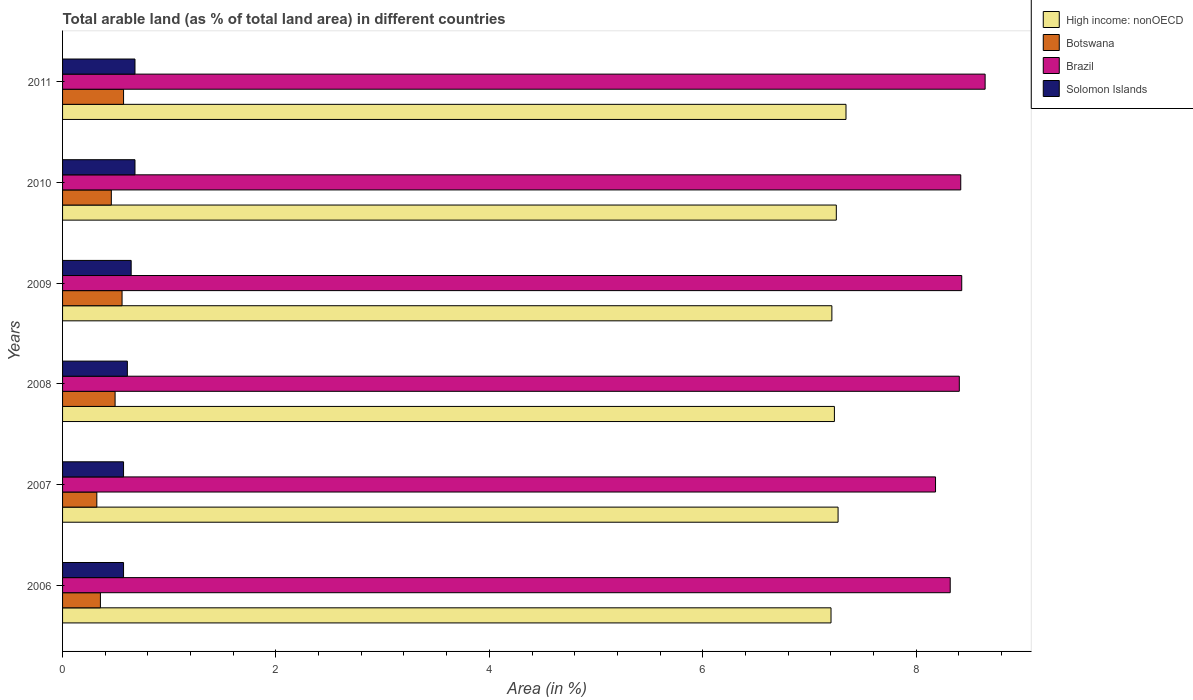How many different coloured bars are there?
Offer a terse response. 4. How many groups of bars are there?
Your answer should be very brief. 6. Are the number of bars per tick equal to the number of legend labels?
Ensure brevity in your answer.  Yes. How many bars are there on the 3rd tick from the top?
Offer a terse response. 4. How many bars are there on the 5th tick from the bottom?
Offer a very short reply. 4. What is the label of the 1st group of bars from the top?
Make the answer very short. 2011. In how many cases, is the number of bars for a given year not equal to the number of legend labels?
Ensure brevity in your answer.  0. What is the percentage of arable land in High income: nonOECD in 2008?
Your answer should be very brief. 7.23. Across all years, what is the maximum percentage of arable land in High income: nonOECD?
Offer a very short reply. 7.34. Across all years, what is the minimum percentage of arable land in High income: nonOECD?
Ensure brevity in your answer.  7.2. What is the total percentage of arable land in High income: nonOECD in the graph?
Offer a very short reply. 43.51. What is the difference between the percentage of arable land in Solomon Islands in 2007 and that in 2011?
Provide a short and direct response. -0.11. What is the difference between the percentage of arable land in Solomon Islands in 2010 and the percentage of arable land in Botswana in 2007?
Ensure brevity in your answer.  0.36. What is the average percentage of arable land in Solomon Islands per year?
Offer a terse response. 0.63. In the year 2011, what is the difference between the percentage of arable land in Botswana and percentage of arable land in High income: nonOECD?
Your answer should be compact. -6.77. What is the ratio of the percentage of arable land in Botswana in 2006 to that in 2007?
Your answer should be very brief. 1.1. Is the difference between the percentage of arable land in Botswana in 2008 and 2009 greater than the difference between the percentage of arable land in High income: nonOECD in 2008 and 2009?
Ensure brevity in your answer.  No. What is the difference between the highest and the second highest percentage of arable land in Solomon Islands?
Your response must be concise. 0. What is the difference between the highest and the lowest percentage of arable land in Botswana?
Give a very brief answer. 0.25. Is it the case that in every year, the sum of the percentage of arable land in Solomon Islands and percentage of arable land in High income: nonOECD is greater than the sum of percentage of arable land in Brazil and percentage of arable land in Botswana?
Provide a short and direct response. No. What does the 3rd bar from the top in 2006 represents?
Your response must be concise. Botswana. What does the 2nd bar from the bottom in 2009 represents?
Your response must be concise. Botswana. Is it the case that in every year, the sum of the percentage of arable land in Solomon Islands and percentage of arable land in Brazil is greater than the percentage of arable land in High income: nonOECD?
Provide a succinct answer. Yes. How many years are there in the graph?
Offer a terse response. 6. What is the difference between two consecutive major ticks on the X-axis?
Make the answer very short. 2. Does the graph contain any zero values?
Keep it short and to the point. No. Where does the legend appear in the graph?
Offer a terse response. Top right. How are the legend labels stacked?
Provide a succinct answer. Vertical. What is the title of the graph?
Offer a terse response. Total arable land (as % of total land area) in different countries. Does "Sub-Saharan Africa (developing only)" appear as one of the legend labels in the graph?
Provide a short and direct response. No. What is the label or title of the X-axis?
Keep it short and to the point. Area (in %). What is the label or title of the Y-axis?
Your answer should be very brief. Years. What is the Area (in %) in High income: nonOECD in 2006?
Provide a succinct answer. 7.2. What is the Area (in %) in Botswana in 2006?
Provide a short and direct response. 0.35. What is the Area (in %) of Brazil in 2006?
Your response must be concise. 8.32. What is the Area (in %) of Solomon Islands in 2006?
Your response must be concise. 0.57. What is the Area (in %) of High income: nonOECD in 2007?
Provide a short and direct response. 7.27. What is the Area (in %) of Botswana in 2007?
Offer a terse response. 0.32. What is the Area (in %) in Brazil in 2007?
Offer a terse response. 8.18. What is the Area (in %) in Solomon Islands in 2007?
Provide a short and direct response. 0.57. What is the Area (in %) of High income: nonOECD in 2008?
Keep it short and to the point. 7.23. What is the Area (in %) in Botswana in 2008?
Offer a very short reply. 0.49. What is the Area (in %) in Brazil in 2008?
Offer a terse response. 8.4. What is the Area (in %) in Solomon Islands in 2008?
Your answer should be very brief. 0.61. What is the Area (in %) of High income: nonOECD in 2009?
Ensure brevity in your answer.  7.21. What is the Area (in %) of Botswana in 2009?
Ensure brevity in your answer.  0.56. What is the Area (in %) in Brazil in 2009?
Provide a succinct answer. 8.43. What is the Area (in %) of Solomon Islands in 2009?
Your answer should be very brief. 0.64. What is the Area (in %) in High income: nonOECD in 2010?
Your answer should be very brief. 7.25. What is the Area (in %) in Botswana in 2010?
Offer a terse response. 0.46. What is the Area (in %) in Brazil in 2010?
Keep it short and to the point. 8.42. What is the Area (in %) of Solomon Islands in 2010?
Your answer should be compact. 0.68. What is the Area (in %) of High income: nonOECD in 2011?
Your response must be concise. 7.34. What is the Area (in %) in Botswana in 2011?
Provide a succinct answer. 0.57. What is the Area (in %) in Brazil in 2011?
Keep it short and to the point. 8.65. What is the Area (in %) in Solomon Islands in 2011?
Give a very brief answer. 0.68. Across all years, what is the maximum Area (in %) of High income: nonOECD?
Make the answer very short. 7.34. Across all years, what is the maximum Area (in %) in Botswana?
Make the answer very short. 0.57. Across all years, what is the maximum Area (in %) of Brazil?
Provide a short and direct response. 8.65. Across all years, what is the maximum Area (in %) in Solomon Islands?
Ensure brevity in your answer.  0.68. Across all years, what is the minimum Area (in %) of High income: nonOECD?
Ensure brevity in your answer.  7.2. Across all years, what is the minimum Area (in %) of Botswana?
Make the answer very short. 0.32. Across all years, what is the minimum Area (in %) in Brazil?
Offer a terse response. 8.18. Across all years, what is the minimum Area (in %) of Solomon Islands?
Give a very brief answer. 0.57. What is the total Area (in %) in High income: nonOECD in the graph?
Keep it short and to the point. 43.51. What is the total Area (in %) in Botswana in the graph?
Make the answer very short. 2.75. What is the total Area (in %) of Brazil in the graph?
Provide a succinct answer. 50.4. What is the total Area (in %) in Solomon Islands in the graph?
Provide a short and direct response. 3.75. What is the difference between the Area (in %) in High income: nonOECD in 2006 and that in 2007?
Offer a very short reply. -0.07. What is the difference between the Area (in %) of Botswana in 2006 and that in 2007?
Your response must be concise. 0.03. What is the difference between the Area (in %) in Brazil in 2006 and that in 2007?
Your response must be concise. 0.14. What is the difference between the Area (in %) of High income: nonOECD in 2006 and that in 2008?
Your answer should be compact. -0.03. What is the difference between the Area (in %) in Botswana in 2006 and that in 2008?
Provide a short and direct response. -0.14. What is the difference between the Area (in %) of Brazil in 2006 and that in 2008?
Your answer should be very brief. -0.09. What is the difference between the Area (in %) of Solomon Islands in 2006 and that in 2008?
Provide a short and direct response. -0.04. What is the difference between the Area (in %) of High income: nonOECD in 2006 and that in 2009?
Provide a short and direct response. -0.01. What is the difference between the Area (in %) of Botswana in 2006 and that in 2009?
Give a very brief answer. -0.2. What is the difference between the Area (in %) of Brazil in 2006 and that in 2009?
Ensure brevity in your answer.  -0.11. What is the difference between the Area (in %) of Solomon Islands in 2006 and that in 2009?
Provide a succinct answer. -0.07. What is the difference between the Area (in %) of High income: nonOECD in 2006 and that in 2010?
Provide a short and direct response. -0.05. What is the difference between the Area (in %) of Botswana in 2006 and that in 2010?
Give a very brief answer. -0.1. What is the difference between the Area (in %) of Brazil in 2006 and that in 2010?
Provide a short and direct response. -0.1. What is the difference between the Area (in %) of Solomon Islands in 2006 and that in 2010?
Ensure brevity in your answer.  -0.11. What is the difference between the Area (in %) in High income: nonOECD in 2006 and that in 2011?
Offer a terse response. -0.14. What is the difference between the Area (in %) of Botswana in 2006 and that in 2011?
Ensure brevity in your answer.  -0.22. What is the difference between the Area (in %) in Brazil in 2006 and that in 2011?
Provide a succinct answer. -0.33. What is the difference between the Area (in %) in Solomon Islands in 2006 and that in 2011?
Give a very brief answer. -0.11. What is the difference between the Area (in %) in High income: nonOECD in 2007 and that in 2008?
Provide a succinct answer. 0.03. What is the difference between the Area (in %) of Botswana in 2007 and that in 2008?
Provide a short and direct response. -0.17. What is the difference between the Area (in %) in Brazil in 2007 and that in 2008?
Ensure brevity in your answer.  -0.22. What is the difference between the Area (in %) in Solomon Islands in 2007 and that in 2008?
Make the answer very short. -0.04. What is the difference between the Area (in %) in High income: nonOECD in 2007 and that in 2009?
Your answer should be very brief. 0.06. What is the difference between the Area (in %) of Botswana in 2007 and that in 2009?
Keep it short and to the point. -0.24. What is the difference between the Area (in %) in Brazil in 2007 and that in 2009?
Offer a very short reply. -0.25. What is the difference between the Area (in %) in Solomon Islands in 2007 and that in 2009?
Provide a succinct answer. -0.07. What is the difference between the Area (in %) in High income: nonOECD in 2007 and that in 2010?
Give a very brief answer. 0.02. What is the difference between the Area (in %) of Botswana in 2007 and that in 2010?
Your answer should be very brief. -0.14. What is the difference between the Area (in %) in Brazil in 2007 and that in 2010?
Offer a very short reply. -0.24. What is the difference between the Area (in %) in Solomon Islands in 2007 and that in 2010?
Provide a succinct answer. -0.11. What is the difference between the Area (in %) in High income: nonOECD in 2007 and that in 2011?
Offer a very short reply. -0.07. What is the difference between the Area (in %) in Botswana in 2007 and that in 2011?
Your answer should be compact. -0.25. What is the difference between the Area (in %) of Brazil in 2007 and that in 2011?
Keep it short and to the point. -0.46. What is the difference between the Area (in %) of Solomon Islands in 2007 and that in 2011?
Keep it short and to the point. -0.11. What is the difference between the Area (in %) of High income: nonOECD in 2008 and that in 2009?
Provide a succinct answer. 0.02. What is the difference between the Area (in %) of Botswana in 2008 and that in 2009?
Offer a terse response. -0.07. What is the difference between the Area (in %) in Brazil in 2008 and that in 2009?
Your answer should be very brief. -0.02. What is the difference between the Area (in %) in Solomon Islands in 2008 and that in 2009?
Your answer should be compact. -0.04. What is the difference between the Area (in %) of High income: nonOECD in 2008 and that in 2010?
Ensure brevity in your answer.  -0.02. What is the difference between the Area (in %) in Botswana in 2008 and that in 2010?
Provide a succinct answer. 0.04. What is the difference between the Area (in %) of Brazil in 2008 and that in 2010?
Make the answer very short. -0.01. What is the difference between the Area (in %) of Solomon Islands in 2008 and that in 2010?
Offer a terse response. -0.07. What is the difference between the Area (in %) of High income: nonOECD in 2008 and that in 2011?
Your answer should be very brief. -0.11. What is the difference between the Area (in %) in Botswana in 2008 and that in 2011?
Your response must be concise. -0.08. What is the difference between the Area (in %) in Brazil in 2008 and that in 2011?
Make the answer very short. -0.24. What is the difference between the Area (in %) in Solomon Islands in 2008 and that in 2011?
Your response must be concise. -0.07. What is the difference between the Area (in %) of High income: nonOECD in 2009 and that in 2010?
Your answer should be very brief. -0.04. What is the difference between the Area (in %) of Botswana in 2009 and that in 2010?
Keep it short and to the point. 0.1. What is the difference between the Area (in %) of Brazil in 2009 and that in 2010?
Offer a terse response. 0.01. What is the difference between the Area (in %) of Solomon Islands in 2009 and that in 2010?
Make the answer very short. -0.04. What is the difference between the Area (in %) in High income: nonOECD in 2009 and that in 2011?
Provide a short and direct response. -0.13. What is the difference between the Area (in %) in Botswana in 2009 and that in 2011?
Your response must be concise. -0.01. What is the difference between the Area (in %) of Brazil in 2009 and that in 2011?
Give a very brief answer. -0.22. What is the difference between the Area (in %) of Solomon Islands in 2009 and that in 2011?
Your response must be concise. -0.04. What is the difference between the Area (in %) in High income: nonOECD in 2010 and that in 2011?
Provide a succinct answer. -0.09. What is the difference between the Area (in %) in Botswana in 2010 and that in 2011?
Your answer should be very brief. -0.11. What is the difference between the Area (in %) in Brazil in 2010 and that in 2011?
Your response must be concise. -0.23. What is the difference between the Area (in %) in High income: nonOECD in 2006 and the Area (in %) in Botswana in 2007?
Offer a very short reply. 6.88. What is the difference between the Area (in %) in High income: nonOECD in 2006 and the Area (in %) in Brazil in 2007?
Offer a terse response. -0.98. What is the difference between the Area (in %) of High income: nonOECD in 2006 and the Area (in %) of Solomon Islands in 2007?
Keep it short and to the point. 6.63. What is the difference between the Area (in %) in Botswana in 2006 and the Area (in %) in Brazil in 2007?
Provide a succinct answer. -7.83. What is the difference between the Area (in %) in Botswana in 2006 and the Area (in %) in Solomon Islands in 2007?
Provide a short and direct response. -0.22. What is the difference between the Area (in %) of Brazil in 2006 and the Area (in %) of Solomon Islands in 2007?
Offer a terse response. 7.75. What is the difference between the Area (in %) of High income: nonOECD in 2006 and the Area (in %) of Botswana in 2008?
Ensure brevity in your answer.  6.71. What is the difference between the Area (in %) of High income: nonOECD in 2006 and the Area (in %) of Brazil in 2008?
Provide a succinct answer. -1.2. What is the difference between the Area (in %) in High income: nonOECD in 2006 and the Area (in %) in Solomon Islands in 2008?
Your answer should be very brief. 6.6. What is the difference between the Area (in %) of Botswana in 2006 and the Area (in %) of Brazil in 2008?
Your answer should be very brief. -8.05. What is the difference between the Area (in %) of Botswana in 2006 and the Area (in %) of Solomon Islands in 2008?
Give a very brief answer. -0.25. What is the difference between the Area (in %) in Brazil in 2006 and the Area (in %) in Solomon Islands in 2008?
Offer a very short reply. 7.71. What is the difference between the Area (in %) of High income: nonOECD in 2006 and the Area (in %) of Botswana in 2009?
Give a very brief answer. 6.64. What is the difference between the Area (in %) in High income: nonOECD in 2006 and the Area (in %) in Brazil in 2009?
Give a very brief answer. -1.23. What is the difference between the Area (in %) in High income: nonOECD in 2006 and the Area (in %) in Solomon Islands in 2009?
Provide a short and direct response. 6.56. What is the difference between the Area (in %) in Botswana in 2006 and the Area (in %) in Brazil in 2009?
Ensure brevity in your answer.  -8.07. What is the difference between the Area (in %) in Botswana in 2006 and the Area (in %) in Solomon Islands in 2009?
Your answer should be compact. -0.29. What is the difference between the Area (in %) in Brazil in 2006 and the Area (in %) in Solomon Islands in 2009?
Ensure brevity in your answer.  7.68. What is the difference between the Area (in %) of High income: nonOECD in 2006 and the Area (in %) of Botswana in 2010?
Give a very brief answer. 6.75. What is the difference between the Area (in %) in High income: nonOECD in 2006 and the Area (in %) in Brazil in 2010?
Provide a succinct answer. -1.22. What is the difference between the Area (in %) of High income: nonOECD in 2006 and the Area (in %) of Solomon Islands in 2010?
Your answer should be compact. 6.52. What is the difference between the Area (in %) in Botswana in 2006 and the Area (in %) in Brazil in 2010?
Keep it short and to the point. -8.06. What is the difference between the Area (in %) in Botswana in 2006 and the Area (in %) in Solomon Islands in 2010?
Your response must be concise. -0.32. What is the difference between the Area (in %) in Brazil in 2006 and the Area (in %) in Solomon Islands in 2010?
Your answer should be very brief. 7.64. What is the difference between the Area (in %) in High income: nonOECD in 2006 and the Area (in %) in Botswana in 2011?
Make the answer very short. 6.63. What is the difference between the Area (in %) in High income: nonOECD in 2006 and the Area (in %) in Brazil in 2011?
Make the answer very short. -1.44. What is the difference between the Area (in %) of High income: nonOECD in 2006 and the Area (in %) of Solomon Islands in 2011?
Make the answer very short. 6.52. What is the difference between the Area (in %) in Botswana in 2006 and the Area (in %) in Brazil in 2011?
Make the answer very short. -8.29. What is the difference between the Area (in %) in Botswana in 2006 and the Area (in %) in Solomon Islands in 2011?
Your answer should be very brief. -0.32. What is the difference between the Area (in %) in Brazil in 2006 and the Area (in %) in Solomon Islands in 2011?
Ensure brevity in your answer.  7.64. What is the difference between the Area (in %) in High income: nonOECD in 2007 and the Area (in %) in Botswana in 2008?
Provide a short and direct response. 6.78. What is the difference between the Area (in %) of High income: nonOECD in 2007 and the Area (in %) of Brazil in 2008?
Ensure brevity in your answer.  -1.14. What is the difference between the Area (in %) in High income: nonOECD in 2007 and the Area (in %) in Solomon Islands in 2008?
Offer a very short reply. 6.66. What is the difference between the Area (in %) in Botswana in 2007 and the Area (in %) in Brazil in 2008?
Give a very brief answer. -8.08. What is the difference between the Area (in %) of Botswana in 2007 and the Area (in %) of Solomon Islands in 2008?
Your answer should be compact. -0.29. What is the difference between the Area (in %) of Brazil in 2007 and the Area (in %) of Solomon Islands in 2008?
Your response must be concise. 7.57. What is the difference between the Area (in %) of High income: nonOECD in 2007 and the Area (in %) of Botswana in 2009?
Your response must be concise. 6.71. What is the difference between the Area (in %) of High income: nonOECD in 2007 and the Area (in %) of Brazil in 2009?
Give a very brief answer. -1.16. What is the difference between the Area (in %) in High income: nonOECD in 2007 and the Area (in %) in Solomon Islands in 2009?
Provide a short and direct response. 6.63. What is the difference between the Area (in %) of Botswana in 2007 and the Area (in %) of Brazil in 2009?
Offer a very short reply. -8.11. What is the difference between the Area (in %) of Botswana in 2007 and the Area (in %) of Solomon Islands in 2009?
Ensure brevity in your answer.  -0.32. What is the difference between the Area (in %) in Brazil in 2007 and the Area (in %) in Solomon Islands in 2009?
Your answer should be very brief. 7.54. What is the difference between the Area (in %) in High income: nonOECD in 2007 and the Area (in %) in Botswana in 2010?
Your answer should be very brief. 6.81. What is the difference between the Area (in %) of High income: nonOECD in 2007 and the Area (in %) of Brazil in 2010?
Ensure brevity in your answer.  -1.15. What is the difference between the Area (in %) in High income: nonOECD in 2007 and the Area (in %) in Solomon Islands in 2010?
Offer a terse response. 6.59. What is the difference between the Area (in %) in Botswana in 2007 and the Area (in %) in Brazil in 2010?
Make the answer very short. -8.1. What is the difference between the Area (in %) of Botswana in 2007 and the Area (in %) of Solomon Islands in 2010?
Your answer should be compact. -0.36. What is the difference between the Area (in %) in Brazil in 2007 and the Area (in %) in Solomon Islands in 2010?
Provide a succinct answer. 7.5. What is the difference between the Area (in %) of High income: nonOECD in 2007 and the Area (in %) of Botswana in 2011?
Your answer should be compact. 6.7. What is the difference between the Area (in %) of High income: nonOECD in 2007 and the Area (in %) of Brazil in 2011?
Ensure brevity in your answer.  -1.38. What is the difference between the Area (in %) of High income: nonOECD in 2007 and the Area (in %) of Solomon Islands in 2011?
Your answer should be compact. 6.59. What is the difference between the Area (in %) of Botswana in 2007 and the Area (in %) of Brazil in 2011?
Provide a succinct answer. -8.33. What is the difference between the Area (in %) of Botswana in 2007 and the Area (in %) of Solomon Islands in 2011?
Your response must be concise. -0.36. What is the difference between the Area (in %) in Brazil in 2007 and the Area (in %) in Solomon Islands in 2011?
Your response must be concise. 7.5. What is the difference between the Area (in %) of High income: nonOECD in 2008 and the Area (in %) of Botswana in 2009?
Your response must be concise. 6.68. What is the difference between the Area (in %) in High income: nonOECD in 2008 and the Area (in %) in Brazil in 2009?
Provide a short and direct response. -1.19. What is the difference between the Area (in %) of High income: nonOECD in 2008 and the Area (in %) of Solomon Islands in 2009?
Your response must be concise. 6.59. What is the difference between the Area (in %) of Botswana in 2008 and the Area (in %) of Brazil in 2009?
Your response must be concise. -7.94. What is the difference between the Area (in %) of Botswana in 2008 and the Area (in %) of Solomon Islands in 2009?
Your response must be concise. -0.15. What is the difference between the Area (in %) of Brazil in 2008 and the Area (in %) of Solomon Islands in 2009?
Offer a very short reply. 7.76. What is the difference between the Area (in %) of High income: nonOECD in 2008 and the Area (in %) of Botswana in 2010?
Your answer should be compact. 6.78. What is the difference between the Area (in %) of High income: nonOECD in 2008 and the Area (in %) of Brazil in 2010?
Your answer should be compact. -1.18. What is the difference between the Area (in %) in High income: nonOECD in 2008 and the Area (in %) in Solomon Islands in 2010?
Ensure brevity in your answer.  6.56. What is the difference between the Area (in %) in Botswana in 2008 and the Area (in %) in Brazil in 2010?
Provide a short and direct response. -7.93. What is the difference between the Area (in %) in Botswana in 2008 and the Area (in %) in Solomon Islands in 2010?
Ensure brevity in your answer.  -0.19. What is the difference between the Area (in %) of Brazil in 2008 and the Area (in %) of Solomon Islands in 2010?
Offer a terse response. 7.73. What is the difference between the Area (in %) in High income: nonOECD in 2008 and the Area (in %) in Botswana in 2011?
Your response must be concise. 6.66. What is the difference between the Area (in %) of High income: nonOECD in 2008 and the Area (in %) of Brazil in 2011?
Your answer should be compact. -1.41. What is the difference between the Area (in %) in High income: nonOECD in 2008 and the Area (in %) in Solomon Islands in 2011?
Provide a succinct answer. 6.56. What is the difference between the Area (in %) in Botswana in 2008 and the Area (in %) in Brazil in 2011?
Offer a very short reply. -8.15. What is the difference between the Area (in %) of Botswana in 2008 and the Area (in %) of Solomon Islands in 2011?
Keep it short and to the point. -0.19. What is the difference between the Area (in %) in Brazil in 2008 and the Area (in %) in Solomon Islands in 2011?
Offer a very short reply. 7.73. What is the difference between the Area (in %) of High income: nonOECD in 2009 and the Area (in %) of Botswana in 2010?
Provide a succinct answer. 6.75. What is the difference between the Area (in %) of High income: nonOECD in 2009 and the Area (in %) of Brazil in 2010?
Ensure brevity in your answer.  -1.21. What is the difference between the Area (in %) of High income: nonOECD in 2009 and the Area (in %) of Solomon Islands in 2010?
Provide a succinct answer. 6.53. What is the difference between the Area (in %) in Botswana in 2009 and the Area (in %) in Brazil in 2010?
Your answer should be very brief. -7.86. What is the difference between the Area (in %) of Botswana in 2009 and the Area (in %) of Solomon Islands in 2010?
Make the answer very short. -0.12. What is the difference between the Area (in %) of Brazil in 2009 and the Area (in %) of Solomon Islands in 2010?
Make the answer very short. 7.75. What is the difference between the Area (in %) in High income: nonOECD in 2009 and the Area (in %) in Botswana in 2011?
Make the answer very short. 6.64. What is the difference between the Area (in %) in High income: nonOECD in 2009 and the Area (in %) in Brazil in 2011?
Ensure brevity in your answer.  -1.44. What is the difference between the Area (in %) in High income: nonOECD in 2009 and the Area (in %) in Solomon Islands in 2011?
Your response must be concise. 6.53. What is the difference between the Area (in %) in Botswana in 2009 and the Area (in %) in Brazil in 2011?
Give a very brief answer. -8.09. What is the difference between the Area (in %) in Botswana in 2009 and the Area (in %) in Solomon Islands in 2011?
Your answer should be very brief. -0.12. What is the difference between the Area (in %) in Brazil in 2009 and the Area (in %) in Solomon Islands in 2011?
Provide a succinct answer. 7.75. What is the difference between the Area (in %) in High income: nonOECD in 2010 and the Area (in %) in Botswana in 2011?
Provide a succinct answer. 6.68. What is the difference between the Area (in %) in High income: nonOECD in 2010 and the Area (in %) in Brazil in 2011?
Your answer should be compact. -1.39. What is the difference between the Area (in %) of High income: nonOECD in 2010 and the Area (in %) of Solomon Islands in 2011?
Your answer should be compact. 6.57. What is the difference between the Area (in %) in Botswana in 2010 and the Area (in %) in Brazil in 2011?
Make the answer very short. -8.19. What is the difference between the Area (in %) in Botswana in 2010 and the Area (in %) in Solomon Islands in 2011?
Your answer should be compact. -0.22. What is the difference between the Area (in %) of Brazil in 2010 and the Area (in %) of Solomon Islands in 2011?
Ensure brevity in your answer.  7.74. What is the average Area (in %) in High income: nonOECD per year?
Offer a very short reply. 7.25. What is the average Area (in %) of Botswana per year?
Offer a terse response. 0.46. What is the average Area (in %) of Solomon Islands per year?
Keep it short and to the point. 0.63. In the year 2006, what is the difference between the Area (in %) in High income: nonOECD and Area (in %) in Botswana?
Your answer should be compact. 6.85. In the year 2006, what is the difference between the Area (in %) in High income: nonOECD and Area (in %) in Brazil?
Give a very brief answer. -1.12. In the year 2006, what is the difference between the Area (in %) of High income: nonOECD and Area (in %) of Solomon Islands?
Provide a succinct answer. 6.63. In the year 2006, what is the difference between the Area (in %) of Botswana and Area (in %) of Brazil?
Make the answer very short. -7.97. In the year 2006, what is the difference between the Area (in %) of Botswana and Area (in %) of Solomon Islands?
Ensure brevity in your answer.  -0.22. In the year 2006, what is the difference between the Area (in %) in Brazil and Area (in %) in Solomon Islands?
Offer a very short reply. 7.75. In the year 2007, what is the difference between the Area (in %) in High income: nonOECD and Area (in %) in Botswana?
Keep it short and to the point. 6.95. In the year 2007, what is the difference between the Area (in %) of High income: nonOECD and Area (in %) of Brazil?
Your answer should be compact. -0.91. In the year 2007, what is the difference between the Area (in %) in High income: nonOECD and Area (in %) in Solomon Islands?
Provide a succinct answer. 6.7. In the year 2007, what is the difference between the Area (in %) in Botswana and Area (in %) in Brazil?
Make the answer very short. -7.86. In the year 2007, what is the difference between the Area (in %) in Botswana and Area (in %) in Solomon Islands?
Your answer should be very brief. -0.25. In the year 2007, what is the difference between the Area (in %) in Brazil and Area (in %) in Solomon Islands?
Make the answer very short. 7.61. In the year 2008, what is the difference between the Area (in %) in High income: nonOECD and Area (in %) in Botswana?
Offer a very short reply. 6.74. In the year 2008, what is the difference between the Area (in %) of High income: nonOECD and Area (in %) of Brazil?
Keep it short and to the point. -1.17. In the year 2008, what is the difference between the Area (in %) in High income: nonOECD and Area (in %) in Solomon Islands?
Your answer should be very brief. 6.63. In the year 2008, what is the difference between the Area (in %) of Botswana and Area (in %) of Brazil?
Give a very brief answer. -7.91. In the year 2008, what is the difference between the Area (in %) in Botswana and Area (in %) in Solomon Islands?
Give a very brief answer. -0.12. In the year 2008, what is the difference between the Area (in %) in Brazil and Area (in %) in Solomon Islands?
Make the answer very short. 7.8. In the year 2009, what is the difference between the Area (in %) of High income: nonOECD and Area (in %) of Botswana?
Offer a very short reply. 6.65. In the year 2009, what is the difference between the Area (in %) in High income: nonOECD and Area (in %) in Brazil?
Your answer should be very brief. -1.22. In the year 2009, what is the difference between the Area (in %) in High income: nonOECD and Area (in %) in Solomon Islands?
Your answer should be very brief. 6.57. In the year 2009, what is the difference between the Area (in %) of Botswana and Area (in %) of Brazil?
Provide a short and direct response. -7.87. In the year 2009, what is the difference between the Area (in %) of Botswana and Area (in %) of Solomon Islands?
Make the answer very short. -0.09. In the year 2009, what is the difference between the Area (in %) of Brazil and Area (in %) of Solomon Islands?
Provide a succinct answer. 7.78. In the year 2010, what is the difference between the Area (in %) in High income: nonOECD and Area (in %) in Botswana?
Your answer should be very brief. 6.8. In the year 2010, what is the difference between the Area (in %) in High income: nonOECD and Area (in %) in Brazil?
Make the answer very short. -1.17. In the year 2010, what is the difference between the Area (in %) in High income: nonOECD and Area (in %) in Solomon Islands?
Give a very brief answer. 6.57. In the year 2010, what is the difference between the Area (in %) of Botswana and Area (in %) of Brazil?
Offer a terse response. -7.96. In the year 2010, what is the difference between the Area (in %) in Botswana and Area (in %) in Solomon Islands?
Offer a very short reply. -0.22. In the year 2010, what is the difference between the Area (in %) in Brazil and Area (in %) in Solomon Islands?
Your response must be concise. 7.74. In the year 2011, what is the difference between the Area (in %) in High income: nonOECD and Area (in %) in Botswana?
Your answer should be compact. 6.77. In the year 2011, what is the difference between the Area (in %) in High income: nonOECD and Area (in %) in Brazil?
Keep it short and to the point. -1.3. In the year 2011, what is the difference between the Area (in %) in High income: nonOECD and Area (in %) in Solomon Islands?
Make the answer very short. 6.66. In the year 2011, what is the difference between the Area (in %) in Botswana and Area (in %) in Brazil?
Your answer should be very brief. -8.08. In the year 2011, what is the difference between the Area (in %) in Botswana and Area (in %) in Solomon Islands?
Provide a succinct answer. -0.11. In the year 2011, what is the difference between the Area (in %) in Brazil and Area (in %) in Solomon Islands?
Your response must be concise. 7.97. What is the ratio of the Area (in %) of High income: nonOECD in 2006 to that in 2007?
Provide a succinct answer. 0.99. What is the ratio of the Area (in %) of Botswana in 2006 to that in 2007?
Your answer should be very brief. 1.1. What is the ratio of the Area (in %) of Brazil in 2006 to that in 2007?
Keep it short and to the point. 1.02. What is the ratio of the Area (in %) of High income: nonOECD in 2006 to that in 2008?
Keep it short and to the point. 1. What is the ratio of the Area (in %) of Botswana in 2006 to that in 2008?
Give a very brief answer. 0.72. What is the ratio of the Area (in %) of Brazil in 2006 to that in 2008?
Your answer should be compact. 0.99. What is the ratio of the Area (in %) in Solomon Islands in 2006 to that in 2008?
Your answer should be very brief. 0.94. What is the ratio of the Area (in %) of High income: nonOECD in 2006 to that in 2009?
Provide a short and direct response. 1. What is the ratio of the Area (in %) of Botswana in 2006 to that in 2009?
Your answer should be very brief. 0.64. What is the ratio of the Area (in %) in Brazil in 2006 to that in 2009?
Offer a very short reply. 0.99. What is the ratio of the Area (in %) in Solomon Islands in 2006 to that in 2009?
Keep it short and to the point. 0.89. What is the ratio of the Area (in %) of Botswana in 2006 to that in 2010?
Provide a short and direct response. 0.78. What is the ratio of the Area (in %) in Brazil in 2006 to that in 2010?
Offer a terse response. 0.99. What is the ratio of the Area (in %) of Solomon Islands in 2006 to that in 2010?
Make the answer very short. 0.84. What is the ratio of the Area (in %) in High income: nonOECD in 2006 to that in 2011?
Ensure brevity in your answer.  0.98. What is the ratio of the Area (in %) in Botswana in 2006 to that in 2011?
Ensure brevity in your answer.  0.62. What is the ratio of the Area (in %) of Brazil in 2006 to that in 2011?
Your answer should be compact. 0.96. What is the ratio of the Area (in %) of Solomon Islands in 2006 to that in 2011?
Your answer should be compact. 0.84. What is the ratio of the Area (in %) of Botswana in 2007 to that in 2008?
Keep it short and to the point. 0.65. What is the ratio of the Area (in %) in Brazil in 2007 to that in 2008?
Ensure brevity in your answer.  0.97. What is the ratio of the Area (in %) of Solomon Islands in 2007 to that in 2008?
Provide a succinct answer. 0.94. What is the ratio of the Area (in %) of Botswana in 2007 to that in 2009?
Ensure brevity in your answer.  0.58. What is the ratio of the Area (in %) of Brazil in 2007 to that in 2009?
Your answer should be very brief. 0.97. What is the ratio of the Area (in %) in Solomon Islands in 2007 to that in 2009?
Keep it short and to the point. 0.89. What is the ratio of the Area (in %) of High income: nonOECD in 2007 to that in 2010?
Provide a short and direct response. 1. What is the ratio of the Area (in %) of Botswana in 2007 to that in 2010?
Your answer should be compact. 0.7. What is the ratio of the Area (in %) in Brazil in 2007 to that in 2010?
Your response must be concise. 0.97. What is the ratio of the Area (in %) of Solomon Islands in 2007 to that in 2010?
Keep it short and to the point. 0.84. What is the ratio of the Area (in %) of Botswana in 2007 to that in 2011?
Offer a terse response. 0.56. What is the ratio of the Area (in %) of Brazil in 2007 to that in 2011?
Provide a succinct answer. 0.95. What is the ratio of the Area (in %) in Solomon Islands in 2007 to that in 2011?
Your response must be concise. 0.84. What is the ratio of the Area (in %) in High income: nonOECD in 2008 to that in 2009?
Ensure brevity in your answer.  1. What is the ratio of the Area (in %) of Botswana in 2008 to that in 2009?
Give a very brief answer. 0.88. What is the ratio of the Area (in %) of Brazil in 2008 to that in 2009?
Offer a terse response. 1. What is the ratio of the Area (in %) of Solomon Islands in 2008 to that in 2009?
Offer a very short reply. 0.94. What is the ratio of the Area (in %) in High income: nonOECD in 2008 to that in 2010?
Make the answer very short. 1. What is the ratio of the Area (in %) of Botswana in 2008 to that in 2010?
Your response must be concise. 1.08. What is the ratio of the Area (in %) of Solomon Islands in 2008 to that in 2010?
Your response must be concise. 0.89. What is the ratio of the Area (in %) in High income: nonOECD in 2008 to that in 2011?
Make the answer very short. 0.99. What is the ratio of the Area (in %) in Botswana in 2008 to that in 2011?
Ensure brevity in your answer.  0.86. What is the ratio of the Area (in %) of Brazil in 2008 to that in 2011?
Your answer should be compact. 0.97. What is the ratio of the Area (in %) of Solomon Islands in 2008 to that in 2011?
Provide a succinct answer. 0.89. What is the ratio of the Area (in %) in High income: nonOECD in 2009 to that in 2010?
Your answer should be very brief. 0.99. What is the ratio of the Area (in %) in Botswana in 2009 to that in 2010?
Offer a very short reply. 1.22. What is the ratio of the Area (in %) of Botswana in 2009 to that in 2011?
Keep it short and to the point. 0.98. What is the ratio of the Area (in %) in Brazil in 2009 to that in 2011?
Provide a succinct answer. 0.97. What is the ratio of the Area (in %) in Solomon Islands in 2009 to that in 2011?
Your response must be concise. 0.95. What is the ratio of the Area (in %) in High income: nonOECD in 2010 to that in 2011?
Your answer should be very brief. 0.99. What is the ratio of the Area (in %) in Botswana in 2010 to that in 2011?
Keep it short and to the point. 0.8. What is the ratio of the Area (in %) of Brazil in 2010 to that in 2011?
Your answer should be compact. 0.97. What is the ratio of the Area (in %) in Solomon Islands in 2010 to that in 2011?
Make the answer very short. 1. What is the difference between the highest and the second highest Area (in %) of High income: nonOECD?
Give a very brief answer. 0.07. What is the difference between the highest and the second highest Area (in %) of Botswana?
Offer a terse response. 0.01. What is the difference between the highest and the second highest Area (in %) of Brazil?
Provide a succinct answer. 0.22. What is the difference between the highest and the lowest Area (in %) in High income: nonOECD?
Provide a succinct answer. 0.14. What is the difference between the highest and the lowest Area (in %) of Botswana?
Offer a very short reply. 0.25. What is the difference between the highest and the lowest Area (in %) of Brazil?
Give a very brief answer. 0.46. What is the difference between the highest and the lowest Area (in %) in Solomon Islands?
Make the answer very short. 0.11. 